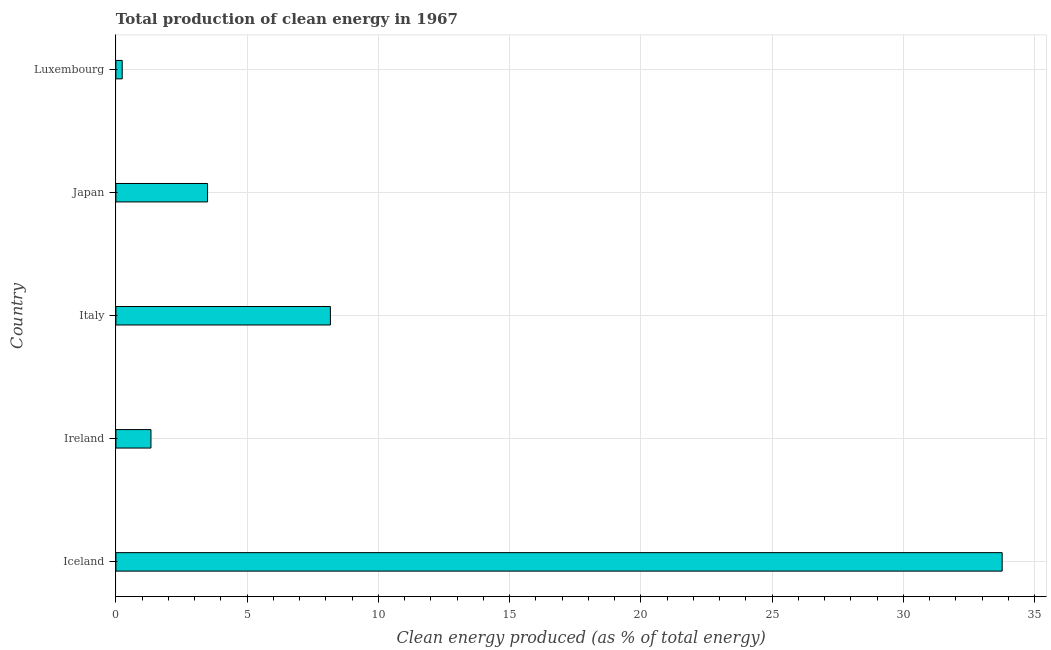Does the graph contain grids?
Your response must be concise. Yes. What is the title of the graph?
Offer a terse response. Total production of clean energy in 1967. What is the label or title of the X-axis?
Keep it short and to the point. Clean energy produced (as % of total energy). What is the label or title of the Y-axis?
Give a very brief answer. Country. What is the production of clean energy in Japan?
Ensure brevity in your answer.  3.49. Across all countries, what is the maximum production of clean energy?
Keep it short and to the point. 33.76. Across all countries, what is the minimum production of clean energy?
Your answer should be very brief. 0.24. In which country was the production of clean energy minimum?
Your response must be concise. Luxembourg. What is the sum of the production of clean energy?
Your response must be concise. 47. What is the difference between the production of clean energy in Italy and Luxembourg?
Ensure brevity in your answer.  7.93. What is the median production of clean energy?
Your response must be concise. 3.49. What is the ratio of the production of clean energy in Iceland to that in Luxembourg?
Ensure brevity in your answer.  140.48. Is the production of clean energy in Ireland less than that in Luxembourg?
Keep it short and to the point. No. Is the difference between the production of clean energy in Iceland and Italy greater than the difference between any two countries?
Ensure brevity in your answer.  No. What is the difference between the highest and the second highest production of clean energy?
Your answer should be very brief. 25.59. Is the sum of the production of clean energy in Ireland and Japan greater than the maximum production of clean energy across all countries?
Ensure brevity in your answer.  No. What is the difference between the highest and the lowest production of clean energy?
Offer a very short reply. 33.52. In how many countries, is the production of clean energy greater than the average production of clean energy taken over all countries?
Your answer should be very brief. 1. How many bars are there?
Provide a short and direct response. 5. Are all the bars in the graph horizontal?
Your answer should be very brief. Yes. What is the Clean energy produced (as % of total energy) of Iceland?
Make the answer very short. 33.76. What is the Clean energy produced (as % of total energy) in Ireland?
Provide a succinct answer. 1.34. What is the Clean energy produced (as % of total energy) of Italy?
Your answer should be compact. 8.17. What is the Clean energy produced (as % of total energy) of Japan?
Offer a terse response. 3.49. What is the Clean energy produced (as % of total energy) of Luxembourg?
Provide a succinct answer. 0.24. What is the difference between the Clean energy produced (as % of total energy) in Iceland and Ireland?
Offer a very short reply. 32.42. What is the difference between the Clean energy produced (as % of total energy) in Iceland and Italy?
Your response must be concise. 25.59. What is the difference between the Clean energy produced (as % of total energy) in Iceland and Japan?
Make the answer very short. 30.27. What is the difference between the Clean energy produced (as % of total energy) in Iceland and Luxembourg?
Make the answer very short. 33.52. What is the difference between the Clean energy produced (as % of total energy) in Ireland and Italy?
Your answer should be very brief. -6.83. What is the difference between the Clean energy produced (as % of total energy) in Ireland and Japan?
Your response must be concise. -2.16. What is the difference between the Clean energy produced (as % of total energy) in Ireland and Luxembourg?
Provide a short and direct response. 1.1. What is the difference between the Clean energy produced (as % of total energy) in Italy and Japan?
Ensure brevity in your answer.  4.68. What is the difference between the Clean energy produced (as % of total energy) in Italy and Luxembourg?
Ensure brevity in your answer.  7.93. What is the difference between the Clean energy produced (as % of total energy) in Japan and Luxembourg?
Provide a short and direct response. 3.25. What is the ratio of the Clean energy produced (as % of total energy) in Iceland to that in Ireland?
Your answer should be very brief. 25.27. What is the ratio of the Clean energy produced (as % of total energy) in Iceland to that in Italy?
Your answer should be compact. 4.13. What is the ratio of the Clean energy produced (as % of total energy) in Iceland to that in Japan?
Provide a short and direct response. 9.67. What is the ratio of the Clean energy produced (as % of total energy) in Iceland to that in Luxembourg?
Make the answer very short. 140.48. What is the ratio of the Clean energy produced (as % of total energy) in Ireland to that in Italy?
Give a very brief answer. 0.16. What is the ratio of the Clean energy produced (as % of total energy) in Ireland to that in Japan?
Offer a terse response. 0.38. What is the ratio of the Clean energy produced (as % of total energy) in Ireland to that in Luxembourg?
Ensure brevity in your answer.  5.56. What is the ratio of the Clean energy produced (as % of total energy) in Italy to that in Japan?
Keep it short and to the point. 2.34. What is the ratio of the Clean energy produced (as % of total energy) in Italy to that in Luxembourg?
Provide a short and direct response. 34. What is the ratio of the Clean energy produced (as % of total energy) in Japan to that in Luxembourg?
Provide a succinct answer. 14.53. 